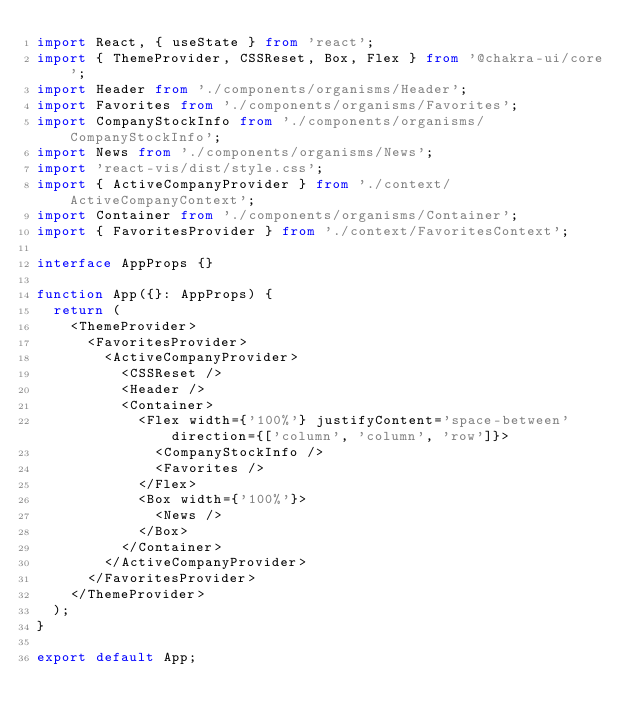Convert code to text. <code><loc_0><loc_0><loc_500><loc_500><_TypeScript_>import React, { useState } from 'react';
import { ThemeProvider, CSSReset, Box, Flex } from '@chakra-ui/core';
import Header from './components/organisms/Header';
import Favorites from './components/organisms/Favorites';
import CompanyStockInfo from './components/organisms/CompanyStockInfo';
import News from './components/organisms/News';
import 'react-vis/dist/style.css';
import { ActiveCompanyProvider } from './context/ActiveCompanyContext';
import Container from './components/organisms/Container';
import { FavoritesProvider } from './context/FavoritesContext';

interface AppProps {}

function App({}: AppProps) {
  return (
    <ThemeProvider>
      <FavoritesProvider>
        <ActiveCompanyProvider>
          <CSSReset />
          <Header />
          <Container>
            <Flex width={'100%'} justifyContent='space-between' direction={['column', 'column', 'row']}>
              <CompanyStockInfo />
              <Favorites />
            </Flex>
            <Box width={'100%'}>
              <News />
            </Box>
          </Container>
        </ActiveCompanyProvider>
      </FavoritesProvider>
    </ThemeProvider>
  );
}

export default App;
</code> 